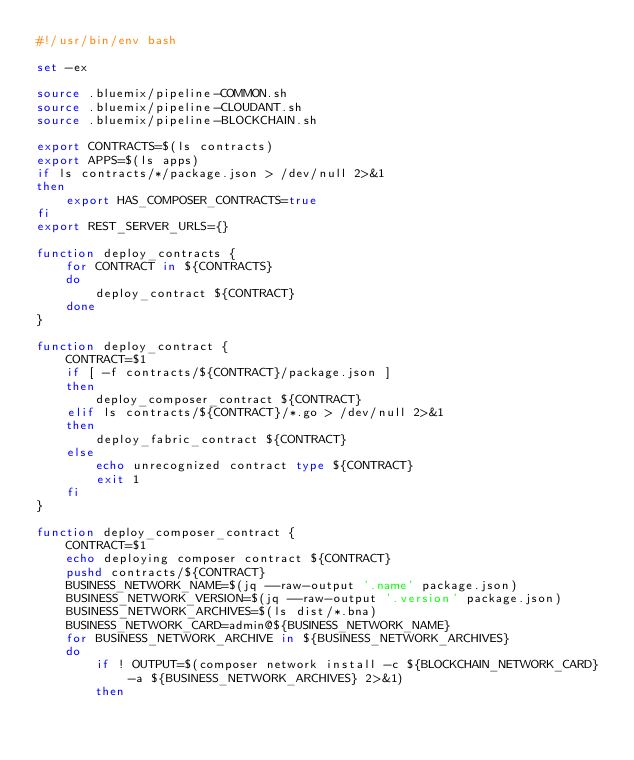<code> <loc_0><loc_0><loc_500><loc_500><_Bash_>#!/usr/bin/env bash

set -ex

source .bluemix/pipeline-COMMON.sh
source .bluemix/pipeline-CLOUDANT.sh
source .bluemix/pipeline-BLOCKCHAIN.sh

export CONTRACTS=$(ls contracts)
export APPS=$(ls apps)
if ls contracts/*/package.json > /dev/null 2>&1
then
    export HAS_COMPOSER_CONTRACTS=true
fi
export REST_SERVER_URLS={}

function deploy_contracts {
    for CONTRACT in ${CONTRACTS}
    do
        deploy_contract ${CONTRACT}
    done
}

function deploy_contract {
    CONTRACT=$1
    if [ -f contracts/${CONTRACT}/package.json ]
    then
        deploy_composer_contract ${CONTRACT}
    elif ls contracts/${CONTRACT}/*.go > /dev/null 2>&1
    then
        deploy_fabric_contract ${CONTRACT}
    else
        echo unrecognized contract type ${CONTRACT}
        exit 1
    fi
}

function deploy_composer_contract {
    CONTRACT=$1
    echo deploying composer contract ${CONTRACT}
    pushd contracts/${CONTRACT}
    BUSINESS_NETWORK_NAME=$(jq --raw-output '.name' package.json)
    BUSINESS_NETWORK_VERSION=$(jq --raw-output '.version' package.json)
    BUSINESS_NETWORK_ARCHIVES=$(ls dist/*.bna)
    BUSINESS_NETWORK_CARD=admin@${BUSINESS_NETWORK_NAME}
    for BUSINESS_NETWORK_ARCHIVE in ${BUSINESS_NETWORK_ARCHIVES}
    do
        if ! OUTPUT=$(composer network install -c ${BLOCKCHAIN_NETWORK_CARD} -a ${BUSINESS_NETWORK_ARCHIVES} 2>&1)
        then</code> 